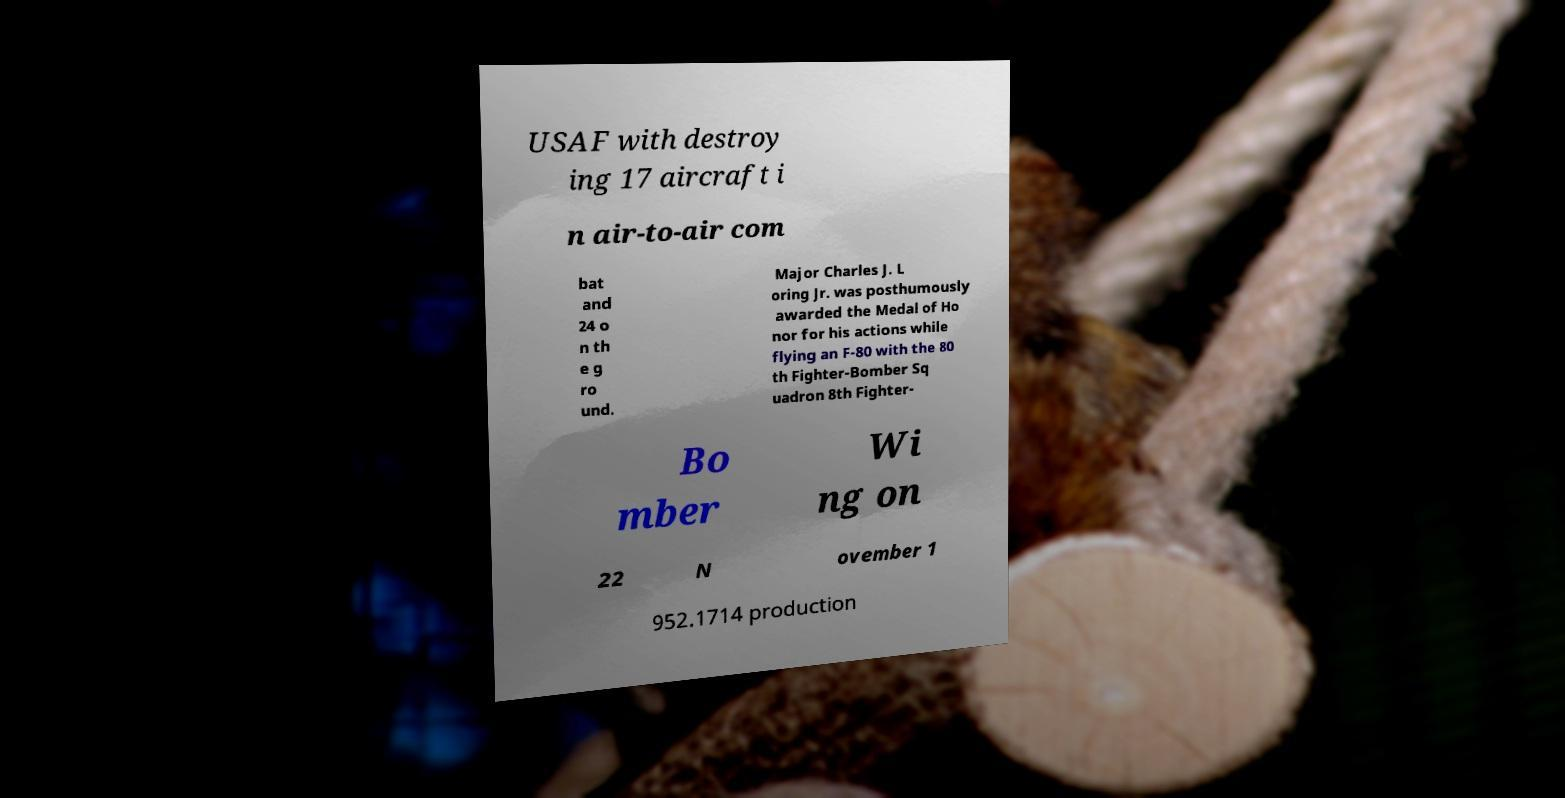For documentation purposes, I need the text within this image transcribed. Could you provide that? USAF with destroy ing 17 aircraft i n air-to-air com bat and 24 o n th e g ro und. Major Charles J. L oring Jr. was posthumously awarded the Medal of Ho nor for his actions while flying an F-80 with the 80 th Fighter-Bomber Sq uadron 8th Fighter- Bo mber Wi ng on 22 N ovember 1 952.1714 production 